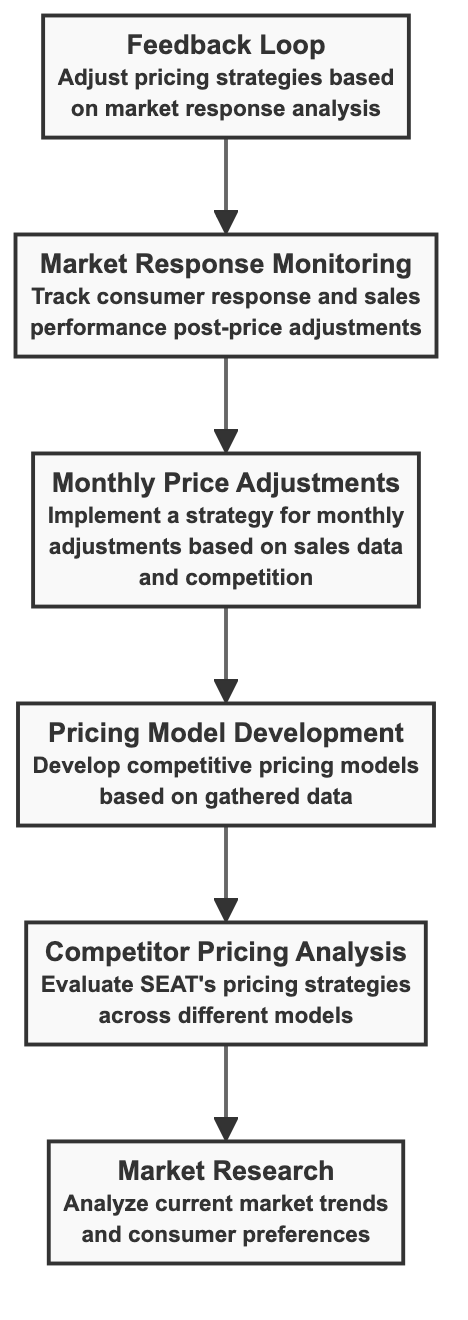What is the first step in the flow? The first step in the flow is "Market Research," which is represented at the top of the diagram as the starting point in the sequence.
Answer: Market Research How many nodes are there in the diagram? The diagram contains a total of six nodes, each representing a distinct component of the competitive pricing strategy overview.
Answer: Six What is the last step in the flow? The last step in the flow is "Feedback Loop," which comes after "Market Response Monitoring" and allows for adjustments based on market responses.
Answer: Feedback Loop Which node follows "Pricing Model Development"? "Monthly Price Adjustments" follows "Pricing Model Development," indicating the next phase in the pricing strategy process after developing the models.
Answer: Monthly Price Adjustments What is the relationship between "Market Response Monitoring" and "Monthly Price Adjustments"? "Market Response Monitoring" is direct output from "Monthly Price Adjustments," as it tracks consumer responses and sales performance following the adjustments made.
Answer: Monitoring follows Adjustments How do the nodes connect in terms of pricing strategy? The nodes are interconnected in a sequential manner, starting from "Market Research" down to "Feedback Loop," indicating a flow of processes that build upon each other to create a coherent pricing strategy.
Answer: Sequential flow Which two nodes are directly linked without any intermediaries? "Monthly Price Adjustments" and "Market Response Monitoring" are directly linked without any nodes in between, indicating a direct continuation in the workflow.
Answer: Monthly Price Adjustments and Market Response Monitoring What flowchart type is this? This is a Bottom Up Flow Chart, as it displays processes in a hierarchical manner, starting from basic research and moving towards a comparative and adaptive strategy.
Answer: Bottom Up Flow Chart 